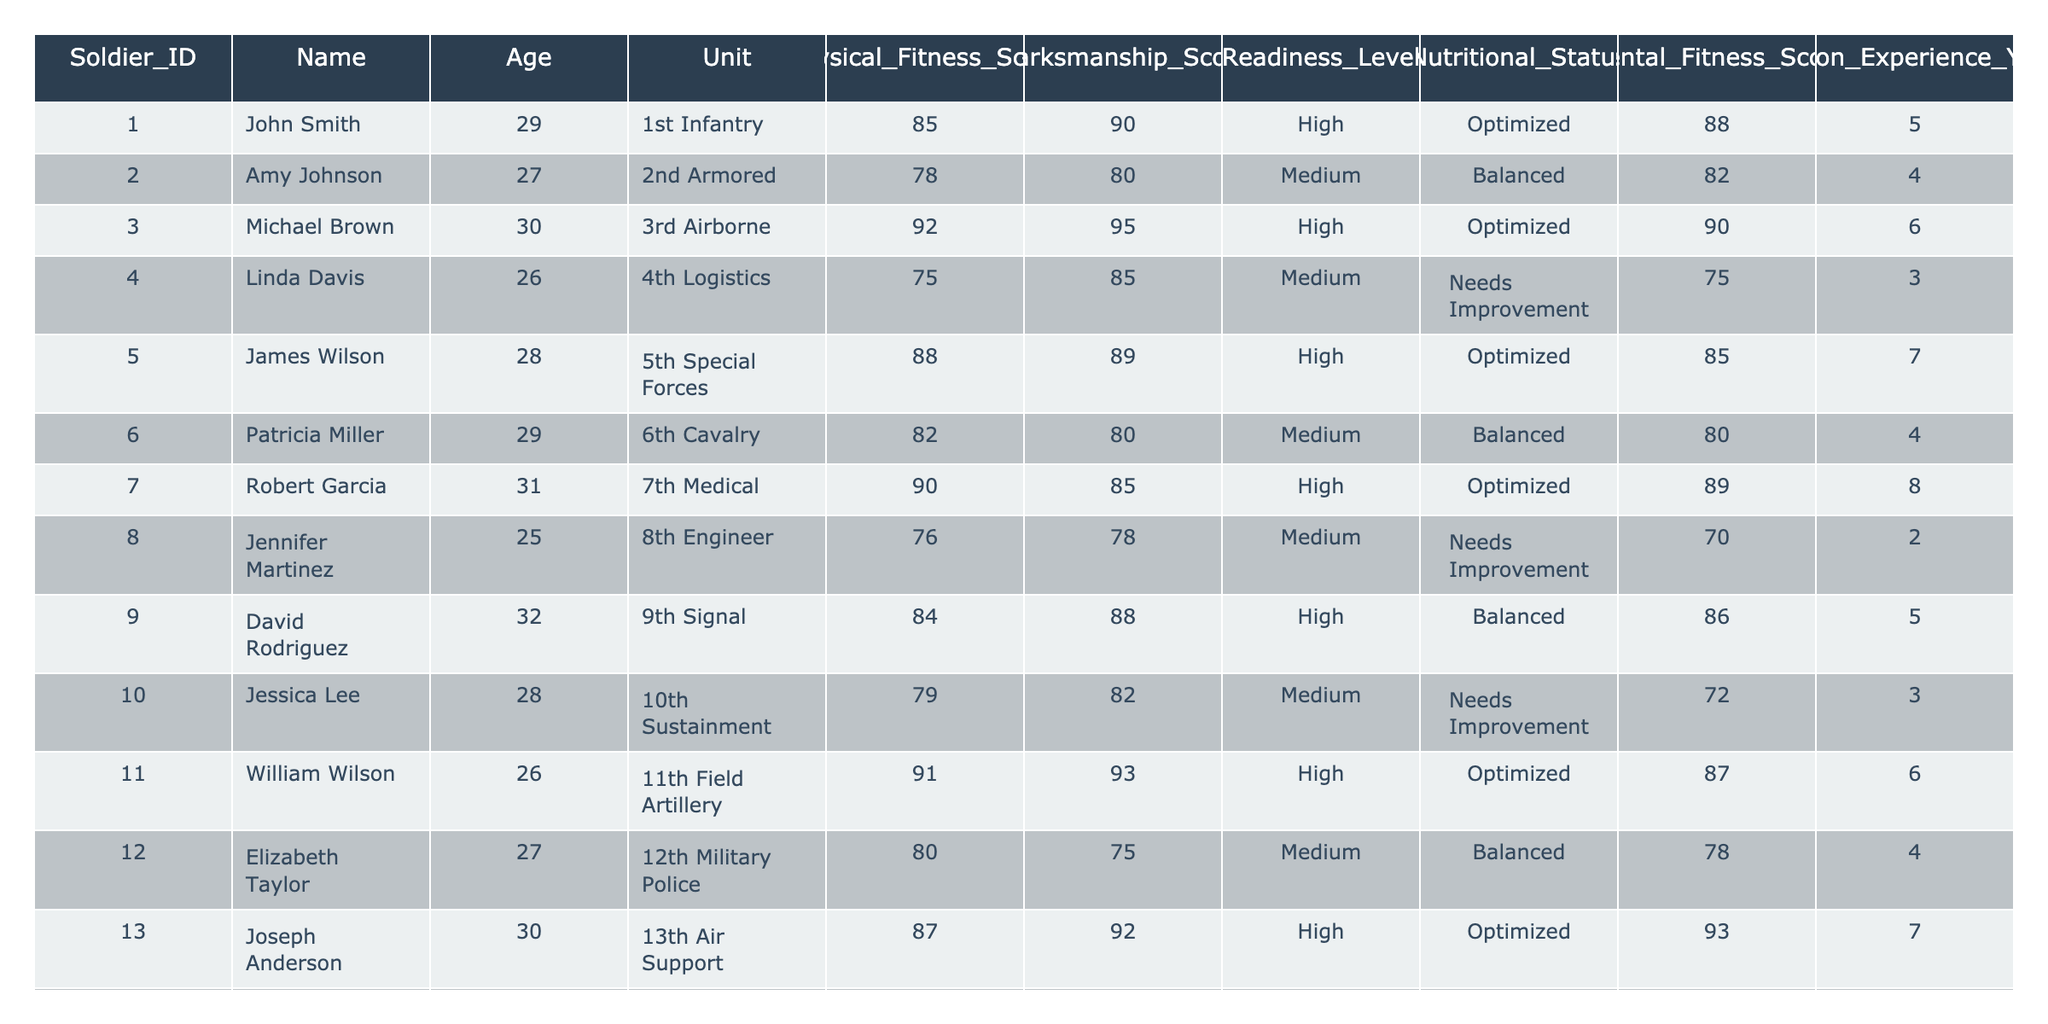What is the Physical Fitness Score of Michael Brown? Michael Brown's entry is in the table under Soldier_ID 003, where the Physical Fitness Score is listed as 92.
Answer: 92 Which soldier has the highest Marksmanship Score? By reviewing the Marksmanship Scores, Michael Brown has the highest score at 95.
Answer: Michael Brown How many soldiers have a High Readiness Level? Counting the entries with a "High" Readiness Level, there are 8 soldiers in total.
Answer: 8 What is the average Age of soldiers in the table? Adding all the Ages (29 + 27 + 30 + 26 + 28 + 29 + 31 + 25 + 32 + 28 + 26 + 27 + 30 + 29 + 28 + 26 + 31 + 27 + 30 + 25 = 573) and dividing by the number of soldiers (20) gives an average Age of 28.65.
Answer: 28.65 Is there any soldier from the 4th Logistics with a Medium Readiness Level? The table shows that Linda Davis from the 4th Logistics has a Medium Readiness Level. Therefore, the statement is true.
Answer: Yes What is the total number of years of Mission Experience for soldiers with an Optimized Nutritional Status? Reviewing the Nutritional Status, the soldiers with "Optimized" are John Smith, Michael Brown, James Wilson, Robert Garcia, William Wilson, Joseph Anderson, Charles Jackson, Thomas Harris, and Daniel Lewis, who collectively have 5 + 6 + 7 + 8 + 6 + 7 + 8 + 6 + 5 = 54 years of Mission Experience.
Answer: 54 Which unit has the lowest average Physical Fitness Score? Calculating the average Physical Fitness Scores for each unit, the 4th Logistics with Linda Davis has the lowest score at 75.
Answer: 4th Logistics Do soldiers over the age of 30 have a better average Mental Fitness Score compared to those under? Soldiers over 30 are Michael Brown, Robert Garcia, and Daniel Lewis with scores 90, 89, and 91, respectively, averaging 90.33. Others below 30 average 83.33 (from the other soldiers). Hence, the over-30 group has a better score.
Answer: Yes How many soldiers have a Balanced Nutritional Status and Medium Readiness Level? By scanning the table, there are three soldiers: Patricia Miller, Elizabeth Taylor, and Jessica Clark that fall into these categories.
Answer: 3 What is the difference between the highest and lowest Physical Fitness Scores in the table? The highest score is 92 (Michael Brown) and the lowest is 75 (Linda Davis). The difference is 92 - 75 = 17.
Answer: 17 Is there a soldier in the 7th Medical with a Low Marksmanship Score? Robert Garcia from the 7th Medical has a Marksmanship Score of 85, which is not low according to any standard, making the statement false.
Answer: No 